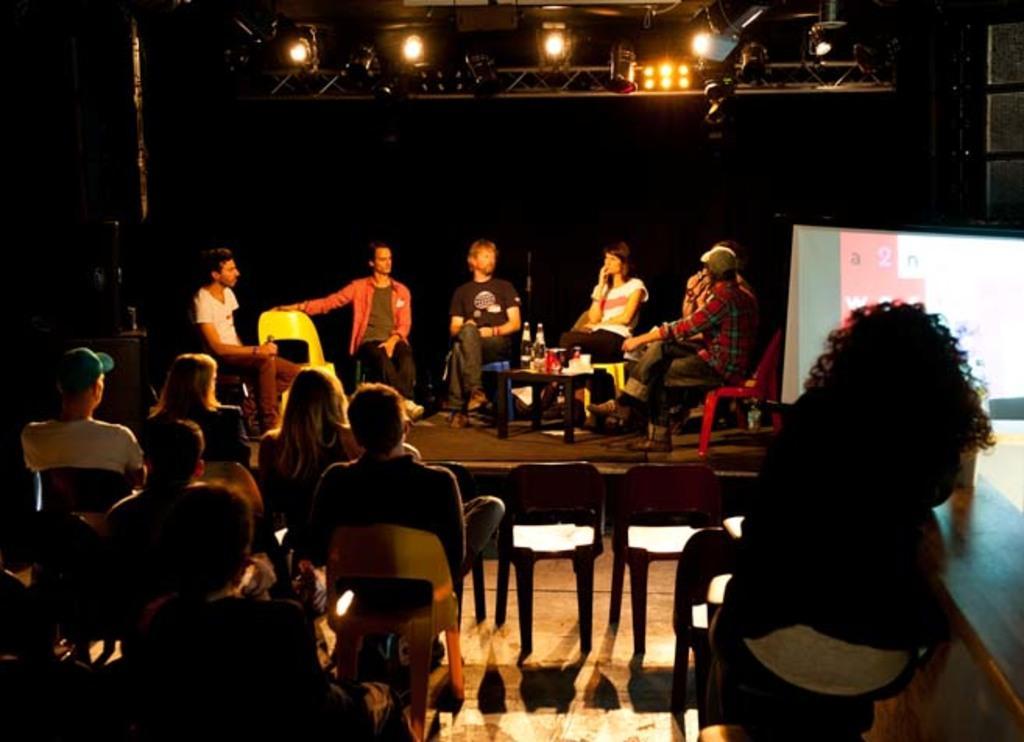Can you describe this image briefly? In this image we can see some people, chairs and other objects. In the background of the image there are some persons, chairs, bottles, table, lights and other objects. 